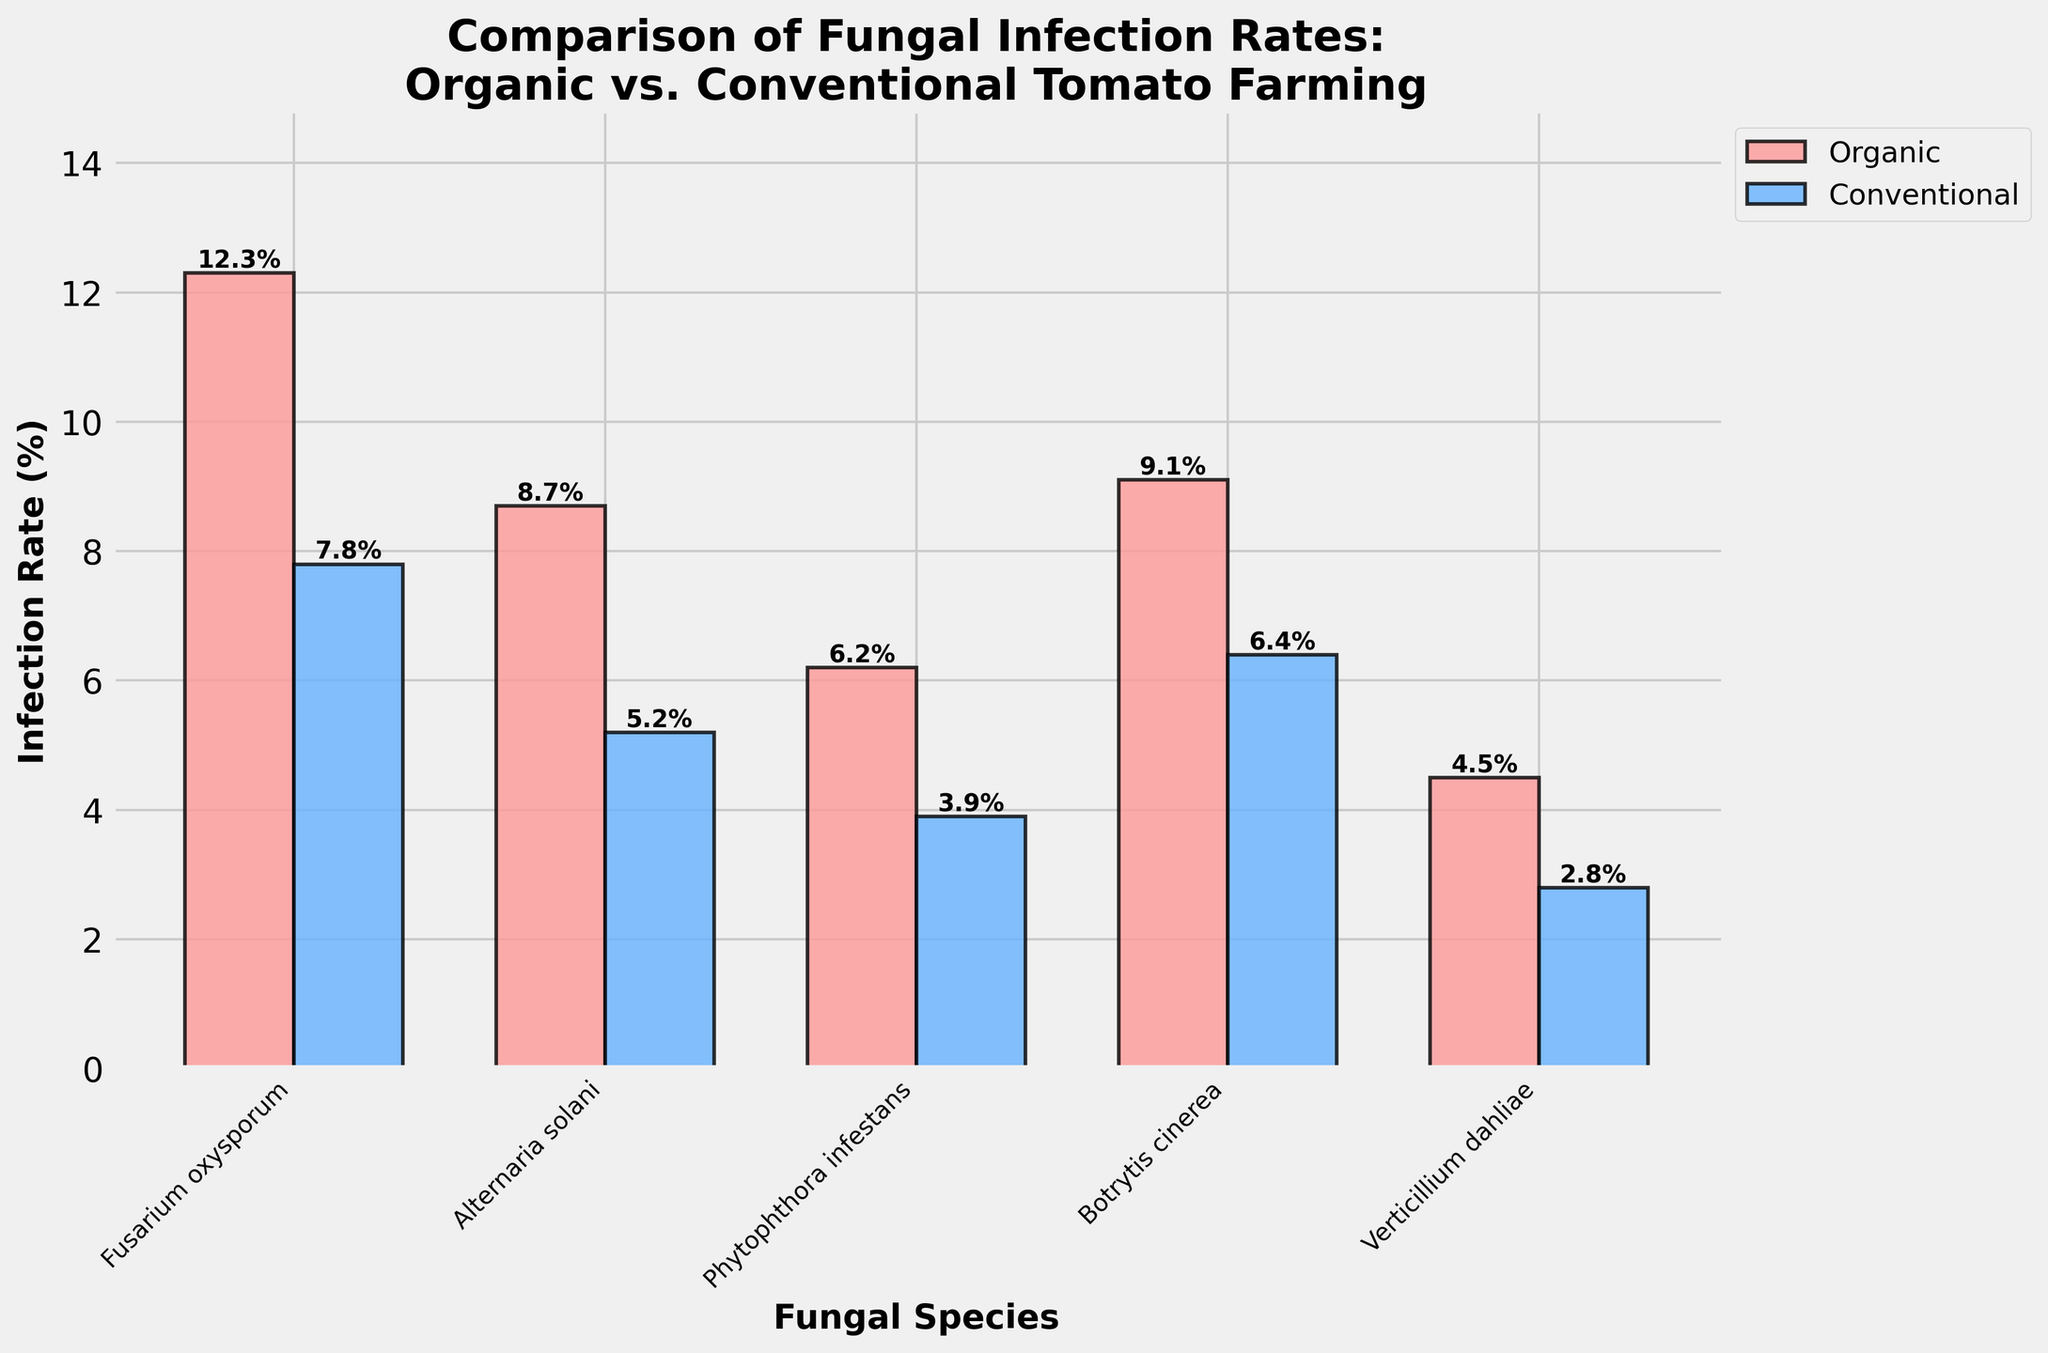Which farming practice has a higher infection rate for Fusarium oxysporum? The height of the bars for Fusarium oxysporum shows 12.3% for Organic and 7.8% for Conventional, indicating Organic has a higher rate.
Answer: Organic What is the difference in infection rates between Organic and Conventional farming for Botrytis cinerea? The infection rate for Botrytis cinerea is 9.1% in Organic and 6.4% in Conventional. The difference is 9.1 - 6.4 = 2.7%.
Answer: 2.7% Which fungal species has the lowest infection rate in Conventional farming? Among the fungal species in Conventional farming, Verticillium dahliae has the lowest infection rate at 2.8%.
Answer: Verticillium dahliae What is the total infection rate for all fungal species in Organic farming? Adding the infection rates for Organic farming: 12.3% + 8.7% + 6.2% + 9.1% + 4.5% = 40.8%.
Answer: 40.8% How much higher is the infection rate for Alternaria solani in Organic farming compared to Conventional farming? Alternaria solani infection rate is 8.7% in Organic and 5.2% in Conventional. The difference is 8.7 - 5.2 = 3.5%.
Answer: 3.5% Which farming practice has a lower average infection rate across all fungal species? The average infection rate for Organic is (12.3% + 8.7% + 6.2% + 9.1% + 4.5%) / 5 = 8.16%. For Conventional, it is (7.8% + 5.2% + 3.9% + 6.4% + 2.8%) / 5 = 5.22%. Conventional has a lower average infection rate.
Answer: Conventional For Phytophthora infestans, what is the ratio of the infection rate in Organic farming to Conventional farming? The infection rate for Phytophthora infestans is 6.2% for Organic and 3.9% for Conventional. The ratio is 6.2 / 3.9 ≈ 1.59.
Answer: 1.59 What is the median infection rate for Organic farming? The infection rates for Organic are 12.3%, 8.7%, 6.2%, 9.1%, and 4.5%. Arranging them in order: 4.5%, 6.2%, 8.7%, 9.1%, 12.3%. The median is 8.7%.
Answer: 8.7% Which farming practice shows more variance in infection rates across fungal species? Organic farming has infection rates of 12.3%, 8.7%, 6.2%, 9.1%, and 4.5% with differences between them appearing more pronounced compared to Conventional farming rates of 7.8%, 5.2%, 3.9%, 6.4%, and 2.8%. To verify, Organic has a standard deviation of approximately 3.14 while Conventional has about 2.01, so Organic shows more variance.
Answer: Organic 